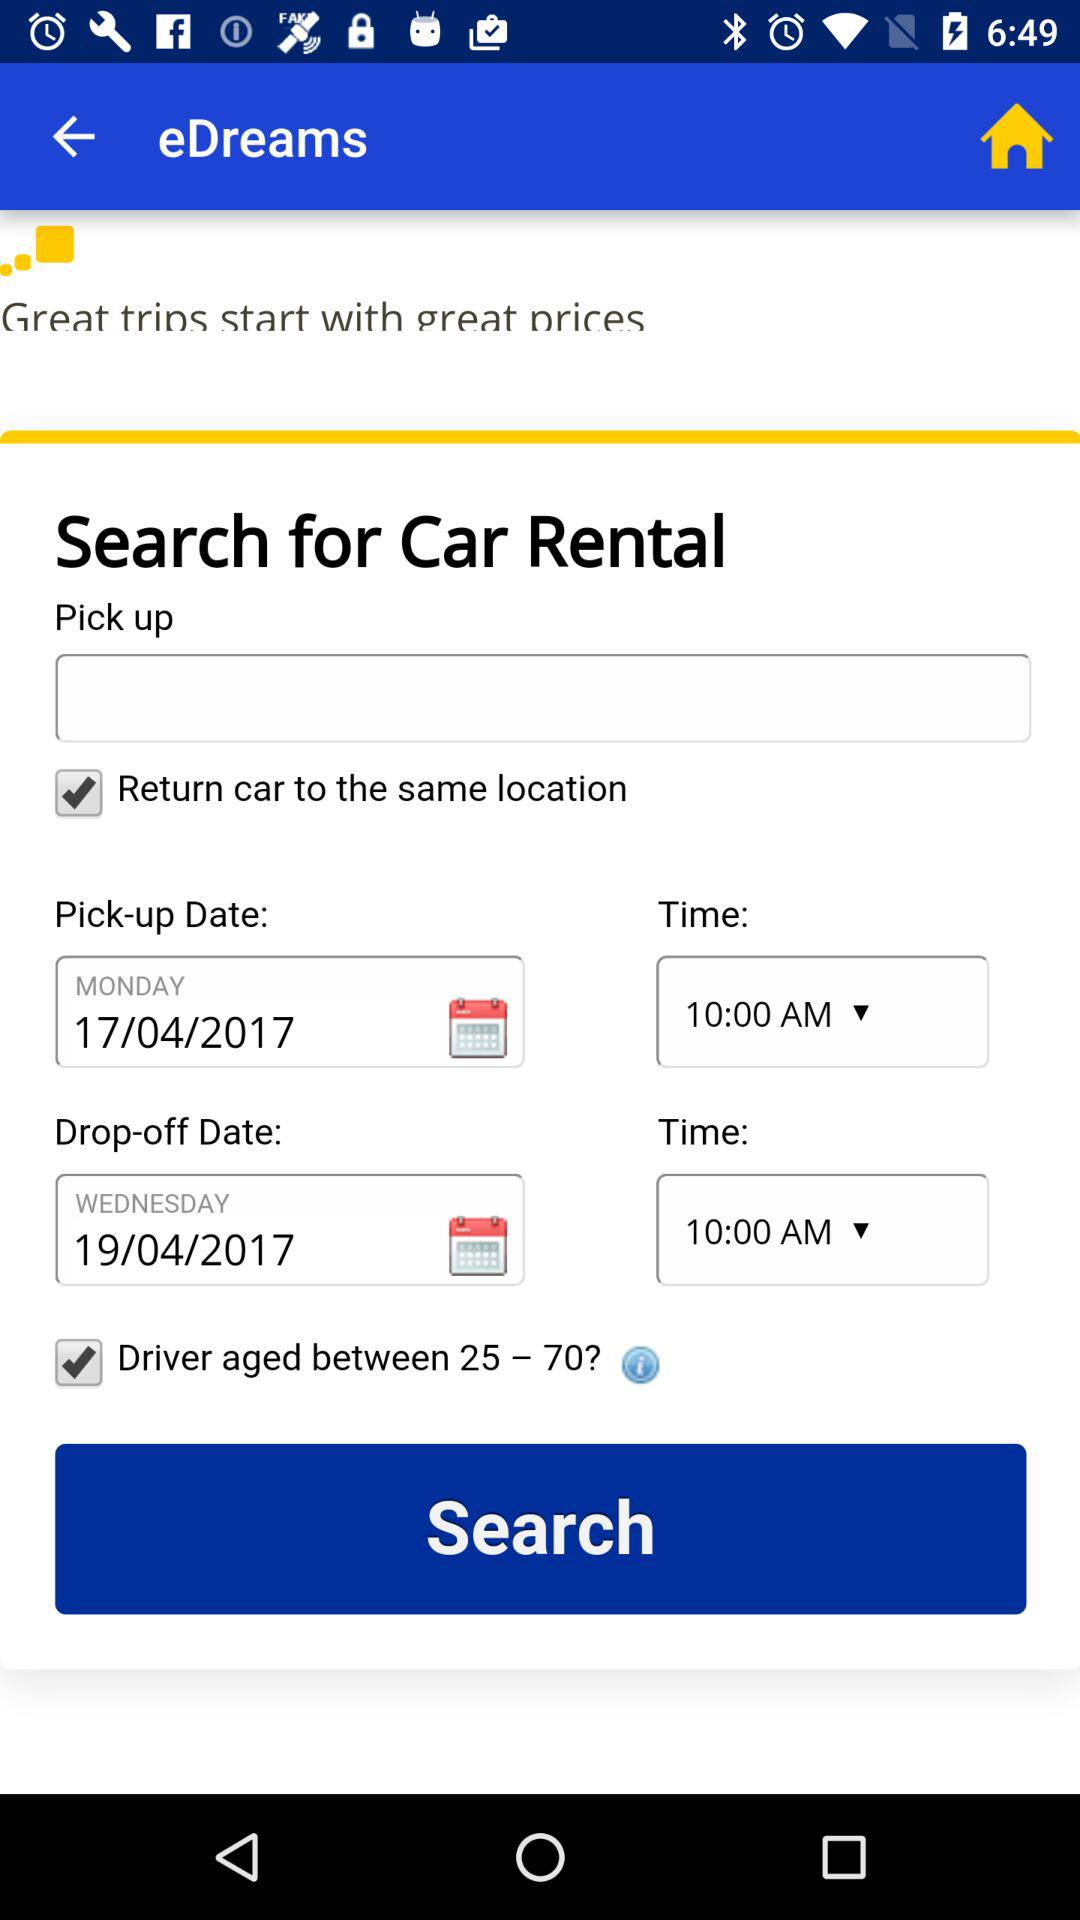What is the drop-off date and time? The drop-off date and time are April 19, 2017 and 10:00 a.m., respectively. 